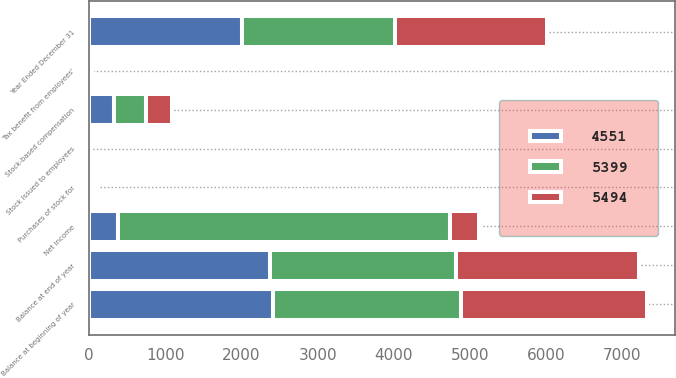Convert chart. <chart><loc_0><loc_0><loc_500><loc_500><stacked_bar_chart><ecel><fcel>Year Ended December 31<fcel>Balance at beginning of year<fcel>Stock issued to employees<fcel>Purchases of stock for<fcel>Balance at end of year<fcel>Tax benefit from employees'<fcel>Stock-based compensation<fcel>Net income<nl><fcel>4551<fcel>2005<fcel>2409<fcel>7<fcel>47<fcel>2369<fcel>11<fcel>324<fcel>383.5<nl><fcel>5494<fcel>2004<fcel>2442<fcel>5<fcel>38<fcel>2409<fcel>13<fcel>345<fcel>383.5<nl><fcel>5399<fcel>2003<fcel>2471<fcel>4<fcel>33<fcel>2442<fcel>11<fcel>422<fcel>4347<nl></chart> 